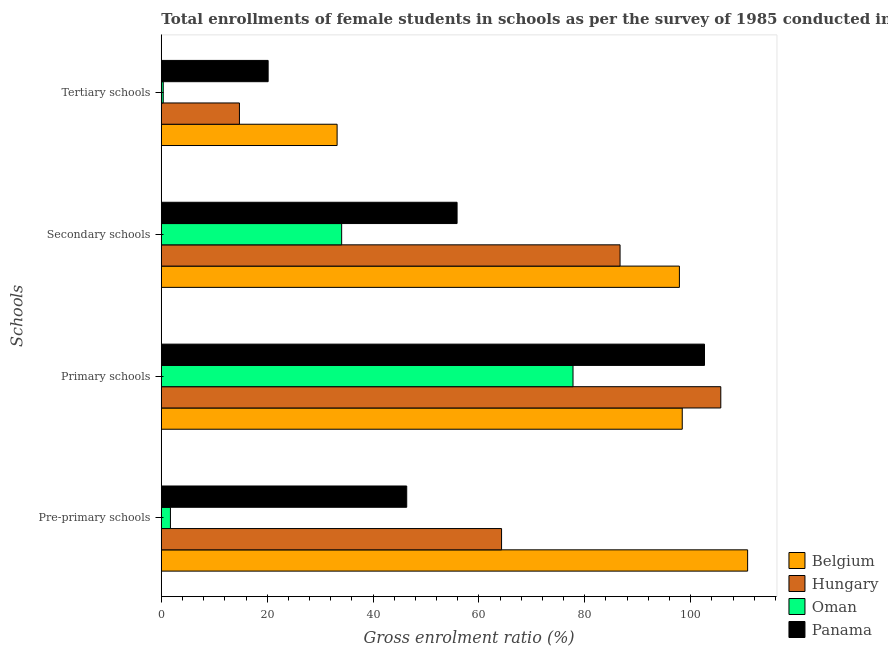How many different coloured bars are there?
Your response must be concise. 4. How many groups of bars are there?
Give a very brief answer. 4. Are the number of bars per tick equal to the number of legend labels?
Offer a terse response. Yes. Are the number of bars on each tick of the Y-axis equal?
Provide a short and direct response. Yes. What is the label of the 2nd group of bars from the top?
Your answer should be very brief. Secondary schools. What is the gross enrolment ratio(female) in secondary schools in Panama?
Keep it short and to the point. 55.87. Across all countries, what is the maximum gross enrolment ratio(female) in primary schools?
Offer a very short reply. 105.69. Across all countries, what is the minimum gross enrolment ratio(female) in tertiary schools?
Make the answer very short. 0.36. In which country was the gross enrolment ratio(female) in tertiary schools maximum?
Give a very brief answer. Belgium. In which country was the gross enrolment ratio(female) in primary schools minimum?
Your answer should be compact. Oman. What is the total gross enrolment ratio(female) in tertiary schools in the graph?
Your answer should be very brief. 68.51. What is the difference between the gross enrolment ratio(female) in secondary schools in Belgium and that in Hungary?
Provide a succinct answer. 11.21. What is the difference between the gross enrolment ratio(female) in primary schools in Oman and the gross enrolment ratio(female) in tertiary schools in Panama?
Your response must be concise. 57.6. What is the average gross enrolment ratio(female) in tertiary schools per country?
Provide a short and direct response. 17.13. What is the difference between the gross enrolment ratio(female) in tertiary schools and gross enrolment ratio(female) in secondary schools in Panama?
Your response must be concise. -35.69. In how many countries, is the gross enrolment ratio(female) in primary schools greater than 64 %?
Provide a succinct answer. 4. What is the ratio of the gross enrolment ratio(female) in secondary schools in Belgium to that in Panama?
Provide a short and direct response. 1.75. Is the difference between the gross enrolment ratio(female) in pre-primary schools in Hungary and Belgium greater than the difference between the gross enrolment ratio(female) in primary schools in Hungary and Belgium?
Your response must be concise. No. What is the difference between the highest and the second highest gross enrolment ratio(female) in primary schools?
Your answer should be compact. 3.08. What is the difference between the highest and the lowest gross enrolment ratio(female) in tertiary schools?
Ensure brevity in your answer.  32.85. In how many countries, is the gross enrolment ratio(female) in tertiary schools greater than the average gross enrolment ratio(female) in tertiary schools taken over all countries?
Offer a very short reply. 2. Is the sum of the gross enrolment ratio(female) in primary schools in Hungary and Panama greater than the maximum gross enrolment ratio(female) in tertiary schools across all countries?
Your answer should be very brief. Yes. Is it the case that in every country, the sum of the gross enrolment ratio(female) in pre-primary schools and gross enrolment ratio(female) in tertiary schools is greater than the sum of gross enrolment ratio(female) in secondary schools and gross enrolment ratio(female) in primary schools?
Offer a very short reply. No. What does the 1st bar from the top in Secondary schools represents?
Ensure brevity in your answer.  Panama. What does the 2nd bar from the bottom in Secondary schools represents?
Your response must be concise. Hungary. What is the difference between two consecutive major ticks on the X-axis?
Provide a succinct answer. 20. Does the graph contain any zero values?
Your response must be concise. No. Does the graph contain grids?
Your response must be concise. No. Where does the legend appear in the graph?
Offer a terse response. Bottom right. How are the legend labels stacked?
Give a very brief answer. Vertical. What is the title of the graph?
Provide a succinct answer. Total enrollments of female students in schools as per the survey of 1985 conducted in different countries. Does "East Asia (developing only)" appear as one of the legend labels in the graph?
Give a very brief answer. No. What is the label or title of the X-axis?
Your response must be concise. Gross enrolment ratio (%). What is the label or title of the Y-axis?
Keep it short and to the point. Schools. What is the Gross enrolment ratio (%) of Belgium in Pre-primary schools?
Your answer should be compact. 110.76. What is the Gross enrolment ratio (%) in Hungary in Pre-primary schools?
Offer a terse response. 64.28. What is the Gross enrolment ratio (%) of Oman in Pre-primary schools?
Provide a succinct answer. 1.72. What is the Gross enrolment ratio (%) of Panama in Pre-primary schools?
Your answer should be compact. 46.36. What is the Gross enrolment ratio (%) in Belgium in Primary schools?
Keep it short and to the point. 98.41. What is the Gross enrolment ratio (%) of Hungary in Primary schools?
Ensure brevity in your answer.  105.69. What is the Gross enrolment ratio (%) in Oman in Primary schools?
Ensure brevity in your answer.  77.78. What is the Gross enrolment ratio (%) of Panama in Primary schools?
Provide a succinct answer. 102.62. What is the Gross enrolment ratio (%) in Belgium in Secondary schools?
Offer a very short reply. 97.88. What is the Gross enrolment ratio (%) of Hungary in Secondary schools?
Provide a succinct answer. 86.66. What is the Gross enrolment ratio (%) of Oman in Secondary schools?
Keep it short and to the point. 34.07. What is the Gross enrolment ratio (%) of Panama in Secondary schools?
Keep it short and to the point. 55.87. What is the Gross enrolment ratio (%) of Belgium in Tertiary schools?
Make the answer very short. 33.21. What is the Gross enrolment ratio (%) of Hungary in Tertiary schools?
Ensure brevity in your answer.  14.76. What is the Gross enrolment ratio (%) in Oman in Tertiary schools?
Offer a terse response. 0.36. What is the Gross enrolment ratio (%) of Panama in Tertiary schools?
Provide a short and direct response. 20.18. Across all Schools, what is the maximum Gross enrolment ratio (%) in Belgium?
Your answer should be compact. 110.76. Across all Schools, what is the maximum Gross enrolment ratio (%) in Hungary?
Your answer should be very brief. 105.69. Across all Schools, what is the maximum Gross enrolment ratio (%) in Oman?
Your response must be concise. 77.78. Across all Schools, what is the maximum Gross enrolment ratio (%) of Panama?
Offer a terse response. 102.62. Across all Schools, what is the minimum Gross enrolment ratio (%) in Belgium?
Provide a short and direct response. 33.21. Across all Schools, what is the minimum Gross enrolment ratio (%) in Hungary?
Give a very brief answer. 14.76. Across all Schools, what is the minimum Gross enrolment ratio (%) of Oman?
Offer a terse response. 0.36. Across all Schools, what is the minimum Gross enrolment ratio (%) in Panama?
Provide a short and direct response. 20.18. What is the total Gross enrolment ratio (%) in Belgium in the graph?
Offer a terse response. 340.26. What is the total Gross enrolment ratio (%) in Hungary in the graph?
Offer a very short reply. 271.4. What is the total Gross enrolment ratio (%) in Oman in the graph?
Give a very brief answer. 113.93. What is the total Gross enrolment ratio (%) in Panama in the graph?
Make the answer very short. 225.03. What is the difference between the Gross enrolment ratio (%) in Belgium in Pre-primary schools and that in Primary schools?
Provide a succinct answer. 12.35. What is the difference between the Gross enrolment ratio (%) of Hungary in Pre-primary schools and that in Primary schools?
Offer a very short reply. -41.42. What is the difference between the Gross enrolment ratio (%) in Oman in Pre-primary schools and that in Primary schools?
Your answer should be compact. -76.05. What is the difference between the Gross enrolment ratio (%) of Panama in Pre-primary schools and that in Primary schools?
Offer a terse response. -56.26. What is the difference between the Gross enrolment ratio (%) of Belgium in Pre-primary schools and that in Secondary schools?
Keep it short and to the point. 12.89. What is the difference between the Gross enrolment ratio (%) of Hungary in Pre-primary schools and that in Secondary schools?
Your answer should be compact. -22.39. What is the difference between the Gross enrolment ratio (%) in Oman in Pre-primary schools and that in Secondary schools?
Ensure brevity in your answer.  -32.35. What is the difference between the Gross enrolment ratio (%) in Panama in Pre-primary schools and that in Secondary schools?
Offer a terse response. -9.52. What is the difference between the Gross enrolment ratio (%) in Belgium in Pre-primary schools and that in Tertiary schools?
Ensure brevity in your answer.  77.55. What is the difference between the Gross enrolment ratio (%) in Hungary in Pre-primary schools and that in Tertiary schools?
Offer a very short reply. 49.52. What is the difference between the Gross enrolment ratio (%) in Oman in Pre-primary schools and that in Tertiary schools?
Your answer should be compact. 1.36. What is the difference between the Gross enrolment ratio (%) in Panama in Pre-primary schools and that in Tertiary schools?
Provide a short and direct response. 26.18. What is the difference between the Gross enrolment ratio (%) in Belgium in Primary schools and that in Secondary schools?
Your answer should be very brief. 0.54. What is the difference between the Gross enrolment ratio (%) in Hungary in Primary schools and that in Secondary schools?
Provide a short and direct response. 19.03. What is the difference between the Gross enrolment ratio (%) of Oman in Primary schools and that in Secondary schools?
Keep it short and to the point. 43.71. What is the difference between the Gross enrolment ratio (%) in Panama in Primary schools and that in Secondary schools?
Your response must be concise. 46.74. What is the difference between the Gross enrolment ratio (%) in Belgium in Primary schools and that in Tertiary schools?
Your response must be concise. 65.2. What is the difference between the Gross enrolment ratio (%) of Hungary in Primary schools and that in Tertiary schools?
Provide a short and direct response. 90.94. What is the difference between the Gross enrolment ratio (%) in Oman in Primary schools and that in Tertiary schools?
Keep it short and to the point. 77.41. What is the difference between the Gross enrolment ratio (%) in Panama in Primary schools and that in Tertiary schools?
Make the answer very short. 82.44. What is the difference between the Gross enrolment ratio (%) in Belgium in Secondary schools and that in Tertiary schools?
Offer a very short reply. 64.66. What is the difference between the Gross enrolment ratio (%) in Hungary in Secondary schools and that in Tertiary schools?
Offer a terse response. 71.91. What is the difference between the Gross enrolment ratio (%) of Oman in Secondary schools and that in Tertiary schools?
Make the answer very short. 33.71. What is the difference between the Gross enrolment ratio (%) in Panama in Secondary schools and that in Tertiary schools?
Offer a very short reply. 35.69. What is the difference between the Gross enrolment ratio (%) in Belgium in Pre-primary schools and the Gross enrolment ratio (%) in Hungary in Primary schools?
Provide a succinct answer. 5.07. What is the difference between the Gross enrolment ratio (%) in Belgium in Pre-primary schools and the Gross enrolment ratio (%) in Oman in Primary schools?
Make the answer very short. 32.99. What is the difference between the Gross enrolment ratio (%) of Belgium in Pre-primary schools and the Gross enrolment ratio (%) of Panama in Primary schools?
Offer a terse response. 8.15. What is the difference between the Gross enrolment ratio (%) in Hungary in Pre-primary schools and the Gross enrolment ratio (%) in Oman in Primary schools?
Offer a very short reply. -13.5. What is the difference between the Gross enrolment ratio (%) in Hungary in Pre-primary schools and the Gross enrolment ratio (%) in Panama in Primary schools?
Provide a short and direct response. -38.34. What is the difference between the Gross enrolment ratio (%) in Oman in Pre-primary schools and the Gross enrolment ratio (%) in Panama in Primary schools?
Your answer should be compact. -100.89. What is the difference between the Gross enrolment ratio (%) of Belgium in Pre-primary schools and the Gross enrolment ratio (%) of Hungary in Secondary schools?
Give a very brief answer. 24.1. What is the difference between the Gross enrolment ratio (%) of Belgium in Pre-primary schools and the Gross enrolment ratio (%) of Oman in Secondary schools?
Provide a succinct answer. 76.7. What is the difference between the Gross enrolment ratio (%) of Belgium in Pre-primary schools and the Gross enrolment ratio (%) of Panama in Secondary schools?
Provide a succinct answer. 54.89. What is the difference between the Gross enrolment ratio (%) of Hungary in Pre-primary schools and the Gross enrolment ratio (%) of Oman in Secondary schools?
Make the answer very short. 30.21. What is the difference between the Gross enrolment ratio (%) in Hungary in Pre-primary schools and the Gross enrolment ratio (%) in Panama in Secondary schools?
Make the answer very short. 8.4. What is the difference between the Gross enrolment ratio (%) of Oman in Pre-primary schools and the Gross enrolment ratio (%) of Panama in Secondary schools?
Offer a very short reply. -54.15. What is the difference between the Gross enrolment ratio (%) of Belgium in Pre-primary schools and the Gross enrolment ratio (%) of Hungary in Tertiary schools?
Make the answer very short. 96.01. What is the difference between the Gross enrolment ratio (%) in Belgium in Pre-primary schools and the Gross enrolment ratio (%) in Oman in Tertiary schools?
Make the answer very short. 110.4. What is the difference between the Gross enrolment ratio (%) in Belgium in Pre-primary schools and the Gross enrolment ratio (%) in Panama in Tertiary schools?
Give a very brief answer. 90.58. What is the difference between the Gross enrolment ratio (%) of Hungary in Pre-primary schools and the Gross enrolment ratio (%) of Oman in Tertiary schools?
Provide a succinct answer. 63.92. What is the difference between the Gross enrolment ratio (%) in Hungary in Pre-primary schools and the Gross enrolment ratio (%) in Panama in Tertiary schools?
Provide a succinct answer. 44.1. What is the difference between the Gross enrolment ratio (%) of Oman in Pre-primary schools and the Gross enrolment ratio (%) of Panama in Tertiary schools?
Provide a succinct answer. -18.46. What is the difference between the Gross enrolment ratio (%) of Belgium in Primary schools and the Gross enrolment ratio (%) of Hungary in Secondary schools?
Provide a short and direct response. 11.75. What is the difference between the Gross enrolment ratio (%) in Belgium in Primary schools and the Gross enrolment ratio (%) in Oman in Secondary schools?
Give a very brief answer. 64.34. What is the difference between the Gross enrolment ratio (%) in Belgium in Primary schools and the Gross enrolment ratio (%) in Panama in Secondary schools?
Provide a succinct answer. 42.54. What is the difference between the Gross enrolment ratio (%) in Hungary in Primary schools and the Gross enrolment ratio (%) in Oman in Secondary schools?
Provide a short and direct response. 71.63. What is the difference between the Gross enrolment ratio (%) in Hungary in Primary schools and the Gross enrolment ratio (%) in Panama in Secondary schools?
Provide a succinct answer. 49.82. What is the difference between the Gross enrolment ratio (%) of Oman in Primary schools and the Gross enrolment ratio (%) of Panama in Secondary schools?
Your answer should be compact. 21.9. What is the difference between the Gross enrolment ratio (%) in Belgium in Primary schools and the Gross enrolment ratio (%) in Hungary in Tertiary schools?
Keep it short and to the point. 83.66. What is the difference between the Gross enrolment ratio (%) in Belgium in Primary schools and the Gross enrolment ratio (%) in Oman in Tertiary schools?
Offer a terse response. 98.05. What is the difference between the Gross enrolment ratio (%) of Belgium in Primary schools and the Gross enrolment ratio (%) of Panama in Tertiary schools?
Provide a succinct answer. 78.23. What is the difference between the Gross enrolment ratio (%) of Hungary in Primary schools and the Gross enrolment ratio (%) of Oman in Tertiary schools?
Your answer should be compact. 105.33. What is the difference between the Gross enrolment ratio (%) of Hungary in Primary schools and the Gross enrolment ratio (%) of Panama in Tertiary schools?
Provide a succinct answer. 85.51. What is the difference between the Gross enrolment ratio (%) in Oman in Primary schools and the Gross enrolment ratio (%) in Panama in Tertiary schools?
Provide a succinct answer. 57.6. What is the difference between the Gross enrolment ratio (%) in Belgium in Secondary schools and the Gross enrolment ratio (%) in Hungary in Tertiary schools?
Ensure brevity in your answer.  83.12. What is the difference between the Gross enrolment ratio (%) of Belgium in Secondary schools and the Gross enrolment ratio (%) of Oman in Tertiary schools?
Your answer should be compact. 97.51. What is the difference between the Gross enrolment ratio (%) of Belgium in Secondary schools and the Gross enrolment ratio (%) of Panama in Tertiary schools?
Give a very brief answer. 77.7. What is the difference between the Gross enrolment ratio (%) in Hungary in Secondary schools and the Gross enrolment ratio (%) in Oman in Tertiary schools?
Offer a very short reply. 86.3. What is the difference between the Gross enrolment ratio (%) of Hungary in Secondary schools and the Gross enrolment ratio (%) of Panama in Tertiary schools?
Provide a short and direct response. 66.48. What is the difference between the Gross enrolment ratio (%) in Oman in Secondary schools and the Gross enrolment ratio (%) in Panama in Tertiary schools?
Keep it short and to the point. 13.89. What is the average Gross enrolment ratio (%) in Belgium per Schools?
Provide a succinct answer. 85.07. What is the average Gross enrolment ratio (%) of Hungary per Schools?
Provide a succinct answer. 67.85. What is the average Gross enrolment ratio (%) in Oman per Schools?
Provide a short and direct response. 28.48. What is the average Gross enrolment ratio (%) in Panama per Schools?
Ensure brevity in your answer.  56.26. What is the difference between the Gross enrolment ratio (%) of Belgium and Gross enrolment ratio (%) of Hungary in Pre-primary schools?
Your answer should be very brief. 46.49. What is the difference between the Gross enrolment ratio (%) in Belgium and Gross enrolment ratio (%) in Oman in Pre-primary schools?
Provide a short and direct response. 109.04. What is the difference between the Gross enrolment ratio (%) in Belgium and Gross enrolment ratio (%) in Panama in Pre-primary schools?
Make the answer very short. 64.41. What is the difference between the Gross enrolment ratio (%) of Hungary and Gross enrolment ratio (%) of Oman in Pre-primary schools?
Your answer should be very brief. 62.56. What is the difference between the Gross enrolment ratio (%) in Hungary and Gross enrolment ratio (%) in Panama in Pre-primary schools?
Make the answer very short. 17.92. What is the difference between the Gross enrolment ratio (%) of Oman and Gross enrolment ratio (%) of Panama in Pre-primary schools?
Give a very brief answer. -44.64. What is the difference between the Gross enrolment ratio (%) in Belgium and Gross enrolment ratio (%) in Hungary in Primary schools?
Your response must be concise. -7.28. What is the difference between the Gross enrolment ratio (%) of Belgium and Gross enrolment ratio (%) of Oman in Primary schools?
Your answer should be compact. 20.64. What is the difference between the Gross enrolment ratio (%) of Belgium and Gross enrolment ratio (%) of Panama in Primary schools?
Your response must be concise. -4.2. What is the difference between the Gross enrolment ratio (%) of Hungary and Gross enrolment ratio (%) of Oman in Primary schools?
Offer a very short reply. 27.92. What is the difference between the Gross enrolment ratio (%) of Hungary and Gross enrolment ratio (%) of Panama in Primary schools?
Ensure brevity in your answer.  3.08. What is the difference between the Gross enrolment ratio (%) in Oman and Gross enrolment ratio (%) in Panama in Primary schools?
Provide a short and direct response. -24.84. What is the difference between the Gross enrolment ratio (%) of Belgium and Gross enrolment ratio (%) of Hungary in Secondary schools?
Provide a succinct answer. 11.21. What is the difference between the Gross enrolment ratio (%) in Belgium and Gross enrolment ratio (%) in Oman in Secondary schools?
Your answer should be compact. 63.81. What is the difference between the Gross enrolment ratio (%) in Belgium and Gross enrolment ratio (%) in Panama in Secondary schools?
Offer a very short reply. 42. What is the difference between the Gross enrolment ratio (%) of Hungary and Gross enrolment ratio (%) of Oman in Secondary schools?
Ensure brevity in your answer.  52.6. What is the difference between the Gross enrolment ratio (%) of Hungary and Gross enrolment ratio (%) of Panama in Secondary schools?
Give a very brief answer. 30.79. What is the difference between the Gross enrolment ratio (%) in Oman and Gross enrolment ratio (%) in Panama in Secondary schools?
Your answer should be compact. -21.81. What is the difference between the Gross enrolment ratio (%) in Belgium and Gross enrolment ratio (%) in Hungary in Tertiary schools?
Offer a terse response. 18.45. What is the difference between the Gross enrolment ratio (%) in Belgium and Gross enrolment ratio (%) in Oman in Tertiary schools?
Provide a succinct answer. 32.85. What is the difference between the Gross enrolment ratio (%) in Belgium and Gross enrolment ratio (%) in Panama in Tertiary schools?
Your answer should be compact. 13.03. What is the difference between the Gross enrolment ratio (%) in Hungary and Gross enrolment ratio (%) in Oman in Tertiary schools?
Your answer should be compact. 14.4. What is the difference between the Gross enrolment ratio (%) of Hungary and Gross enrolment ratio (%) of Panama in Tertiary schools?
Provide a succinct answer. -5.42. What is the difference between the Gross enrolment ratio (%) in Oman and Gross enrolment ratio (%) in Panama in Tertiary schools?
Offer a very short reply. -19.82. What is the ratio of the Gross enrolment ratio (%) in Belgium in Pre-primary schools to that in Primary schools?
Your response must be concise. 1.13. What is the ratio of the Gross enrolment ratio (%) of Hungary in Pre-primary schools to that in Primary schools?
Your answer should be very brief. 0.61. What is the ratio of the Gross enrolment ratio (%) of Oman in Pre-primary schools to that in Primary schools?
Your answer should be compact. 0.02. What is the ratio of the Gross enrolment ratio (%) of Panama in Pre-primary schools to that in Primary schools?
Provide a short and direct response. 0.45. What is the ratio of the Gross enrolment ratio (%) of Belgium in Pre-primary schools to that in Secondary schools?
Your answer should be very brief. 1.13. What is the ratio of the Gross enrolment ratio (%) of Hungary in Pre-primary schools to that in Secondary schools?
Offer a very short reply. 0.74. What is the ratio of the Gross enrolment ratio (%) of Oman in Pre-primary schools to that in Secondary schools?
Your answer should be compact. 0.05. What is the ratio of the Gross enrolment ratio (%) of Panama in Pre-primary schools to that in Secondary schools?
Provide a short and direct response. 0.83. What is the ratio of the Gross enrolment ratio (%) of Belgium in Pre-primary schools to that in Tertiary schools?
Offer a very short reply. 3.34. What is the ratio of the Gross enrolment ratio (%) of Hungary in Pre-primary schools to that in Tertiary schools?
Offer a very short reply. 4.36. What is the ratio of the Gross enrolment ratio (%) in Oman in Pre-primary schools to that in Tertiary schools?
Your answer should be compact. 4.75. What is the ratio of the Gross enrolment ratio (%) in Panama in Pre-primary schools to that in Tertiary schools?
Your answer should be very brief. 2.3. What is the ratio of the Gross enrolment ratio (%) in Hungary in Primary schools to that in Secondary schools?
Offer a terse response. 1.22. What is the ratio of the Gross enrolment ratio (%) of Oman in Primary schools to that in Secondary schools?
Ensure brevity in your answer.  2.28. What is the ratio of the Gross enrolment ratio (%) of Panama in Primary schools to that in Secondary schools?
Your response must be concise. 1.84. What is the ratio of the Gross enrolment ratio (%) in Belgium in Primary schools to that in Tertiary schools?
Your answer should be very brief. 2.96. What is the ratio of the Gross enrolment ratio (%) in Hungary in Primary schools to that in Tertiary schools?
Give a very brief answer. 7.16. What is the ratio of the Gross enrolment ratio (%) in Oman in Primary schools to that in Tertiary schools?
Your answer should be very brief. 214.48. What is the ratio of the Gross enrolment ratio (%) in Panama in Primary schools to that in Tertiary schools?
Your response must be concise. 5.08. What is the ratio of the Gross enrolment ratio (%) of Belgium in Secondary schools to that in Tertiary schools?
Keep it short and to the point. 2.95. What is the ratio of the Gross enrolment ratio (%) of Hungary in Secondary schools to that in Tertiary schools?
Keep it short and to the point. 5.87. What is the ratio of the Gross enrolment ratio (%) of Oman in Secondary schools to that in Tertiary schools?
Your response must be concise. 93.95. What is the ratio of the Gross enrolment ratio (%) of Panama in Secondary schools to that in Tertiary schools?
Offer a very short reply. 2.77. What is the difference between the highest and the second highest Gross enrolment ratio (%) of Belgium?
Your answer should be compact. 12.35. What is the difference between the highest and the second highest Gross enrolment ratio (%) of Hungary?
Offer a very short reply. 19.03. What is the difference between the highest and the second highest Gross enrolment ratio (%) in Oman?
Your answer should be very brief. 43.71. What is the difference between the highest and the second highest Gross enrolment ratio (%) of Panama?
Your response must be concise. 46.74. What is the difference between the highest and the lowest Gross enrolment ratio (%) in Belgium?
Your response must be concise. 77.55. What is the difference between the highest and the lowest Gross enrolment ratio (%) of Hungary?
Keep it short and to the point. 90.94. What is the difference between the highest and the lowest Gross enrolment ratio (%) of Oman?
Provide a succinct answer. 77.41. What is the difference between the highest and the lowest Gross enrolment ratio (%) in Panama?
Provide a succinct answer. 82.44. 